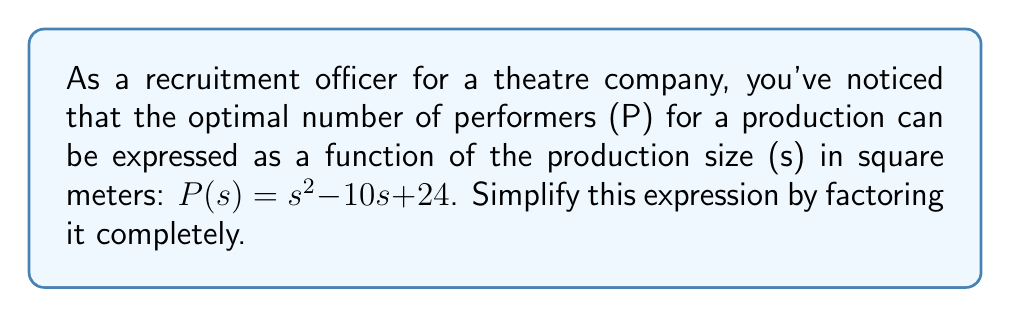Can you solve this math problem? To simplify the expression $P(s) = s^2 - 10s + 24$ by factoring, we'll follow these steps:

1) First, we recognize that this is a quadratic expression in the form $ax^2 + bx + c$, where:
   $a = 1$
   $b = -10$
   $c = 24$

2) To factor this quadratic, we need to find two numbers that multiply to give $ac$ (which is 1 * 24 = 24) and add up to $b$ (-10).

3) The factors of 24 are: ±1, ±2, ±3, ±4, ±6, ±8, ±12, ±24

4) By inspection or trial and error, we find that -6 and -4 satisfy our conditions:
   $-6 * -4 = 24$
   $-6 + (-4) = -10$

5) We can now rewrite the middle term using these numbers:
   $P(s) = s^2 - 6s - 4s + 24$

6) Grouping the terms:
   $P(s) = (s^2 - 6s) + (-4s + 24)$

7) Factoring out the common factors from each group:
   $P(s) = s(s - 6) - 4(s - 6)$

8) We can now factor out the common binomial $(s - 6)$:
   $P(s) = (s - 6)(s - 4)$

This is the fully factored form of the original expression.
Answer: $P(s) = (s - 6)(s - 4)$ 